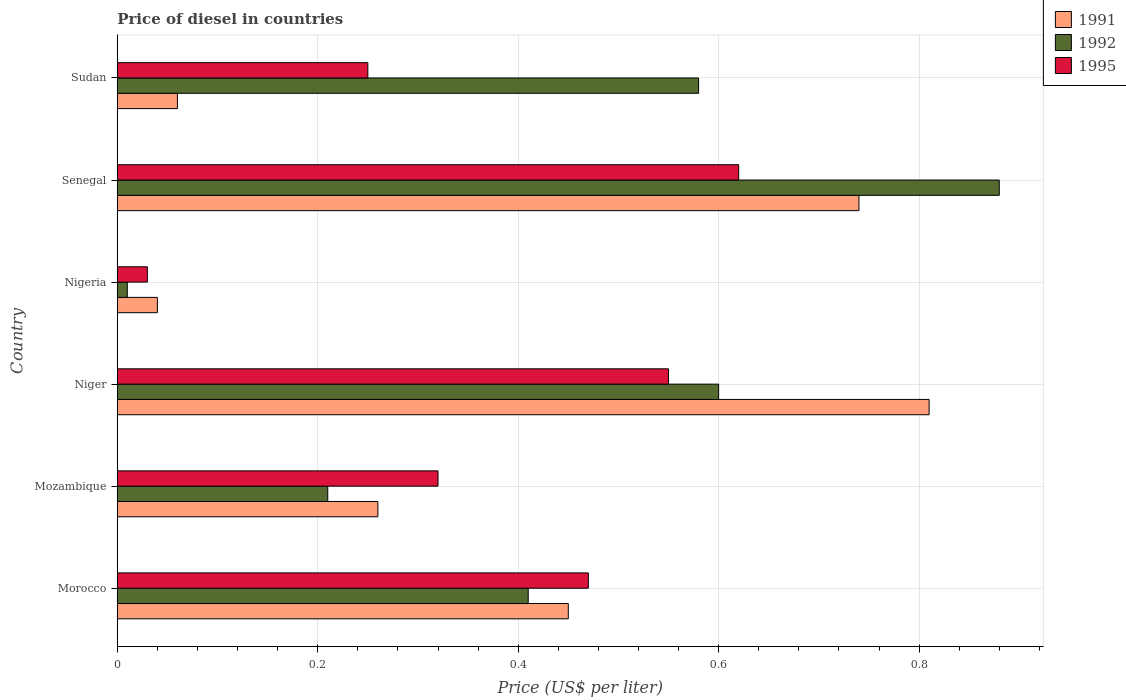What is the label of the 3rd group of bars from the top?
Ensure brevity in your answer.  Nigeria. In how many cases, is the number of bars for a given country not equal to the number of legend labels?
Your answer should be very brief. 0. What is the price of diesel in 1995 in Morocco?
Make the answer very short. 0.47. Across all countries, what is the maximum price of diesel in 1991?
Give a very brief answer. 0.81. In which country was the price of diesel in 1992 maximum?
Provide a succinct answer. Senegal. In which country was the price of diesel in 1991 minimum?
Provide a succinct answer. Nigeria. What is the total price of diesel in 1995 in the graph?
Offer a terse response. 2.24. What is the difference between the price of diesel in 1991 in Senegal and that in Sudan?
Make the answer very short. 0.68. What is the difference between the price of diesel in 1992 in Sudan and the price of diesel in 1991 in Morocco?
Your response must be concise. 0.13. What is the average price of diesel in 1995 per country?
Make the answer very short. 0.37. What is the difference between the price of diesel in 1992 and price of diesel in 1991 in Sudan?
Provide a short and direct response. 0.52. What is the ratio of the price of diesel in 1992 in Nigeria to that in Sudan?
Offer a very short reply. 0.02. Is the price of diesel in 1991 in Morocco less than that in Nigeria?
Give a very brief answer. No. Is the difference between the price of diesel in 1992 in Niger and Sudan greater than the difference between the price of diesel in 1991 in Niger and Sudan?
Your answer should be very brief. No. What is the difference between the highest and the second highest price of diesel in 1991?
Make the answer very short. 0.07. What is the difference between the highest and the lowest price of diesel in 1992?
Offer a very short reply. 0.87. Is the sum of the price of diesel in 1991 in Niger and Senegal greater than the maximum price of diesel in 1992 across all countries?
Your answer should be very brief. Yes. What does the 2nd bar from the top in Mozambique represents?
Your answer should be compact. 1992. Is it the case that in every country, the sum of the price of diesel in 1991 and price of diesel in 1992 is greater than the price of diesel in 1995?
Keep it short and to the point. Yes. How many countries are there in the graph?
Provide a succinct answer. 6. Are the values on the major ticks of X-axis written in scientific E-notation?
Your response must be concise. No. Does the graph contain any zero values?
Your answer should be very brief. No. Does the graph contain grids?
Your answer should be compact. Yes. Where does the legend appear in the graph?
Keep it short and to the point. Top right. What is the title of the graph?
Give a very brief answer. Price of diesel in countries. What is the label or title of the X-axis?
Offer a very short reply. Price (US$ per liter). What is the Price (US$ per liter) in 1991 in Morocco?
Ensure brevity in your answer.  0.45. What is the Price (US$ per liter) in 1992 in Morocco?
Provide a succinct answer. 0.41. What is the Price (US$ per liter) in 1995 in Morocco?
Provide a short and direct response. 0.47. What is the Price (US$ per liter) in 1991 in Mozambique?
Offer a very short reply. 0.26. What is the Price (US$ per liter) of 1992 in Mozambique?
Make the answer very short. 0.21. What is the Price (US$ per liter) in 1995 in Mozambique?
Your response must be concise. 0.32. What is the Price (US$ per liter) of 1991 in Niger?
Give a very brief answer. 0.81. What is the Price (US$ per liter) of 1995 in Niger?
Ensure brevity in your answer.  0.55. What is the Price (US$ per liter) of 1992 in Nigeria?
Ensure brevity in your answer.  0.01. What is the Price (US$ per liter) of 1995 in Nigeria?
Your response must be concise. 0.03. What is the Price (US$ per liter) in 1991 in Senegal?
Your response must be concise. 0.74. What is the Price (US$ per liter) of 1995 in Senegal?
Ensure brevity in your answer.  0.62. What is the Price (US$ per liter) in 1991 in Sudan?
Provide a short and direct response. 0.06. What is the Price (US$ per liter) in 1992 in Sudan?
Give a very brief answer. 0.58. What is the Price (US$ per liter) of 1995 in Sudan?
Keep it short and to the point. 0.25. Across all countries, what is the maximum Price (US$ per liter) in 1991?
Your answer should be compact. 0.81. Across all countries, what is the maximum Price (US$ per liter) in 1995?
Ensure brevity in your answer.  0.62. Across all countries, what is the minimum Price (US$ per liter) in 1995?
Provide a short and direct response. 0.03. What is the total Price (US$ per liter) of 1991 in the graph?
Give a very brief answer. 2.36. What is the total Price (US$ per liter) in 1992 in the graph?
Give a very brief answer. 2.69. What is the total Price (US$ per liter) in 1995 in the graph?
Offer a terse response. 2.24. What is the difference between the Price (US$ per liter) in 1991 in Morocco and that in Mozambique?
Your answer should be compact. 0.19. What is the difference between the Price (US$ per liter) in 1995 in Morocco and that in Mozambique?
Your answer should be compact. 0.15. What is the difference between the Price (US$ per liter) in 1991 in Morocco and that in Niger?
Your answer should be very brief. -0.36. What is the difference between the Price (US$ per liter) of 1992 in Morocco and that in Niger?
Offer a very short reply. -0.19. What is the difference between the Price (US$ per liter) of 1995 in Morocco and that in Niger?
Make the answer very short. -0.08. What is the difference between the Price (US$ per liter) of 1991 in Morocco and that in Nigeria?
Offer a very short reply. 0.41. What is the difference between the Price (US$ per liter) of 1995 in Morocco and that in Nigeria?
Offer a terse response. 0.44. What is the difference between the Price (US$ per liter) in 1991 in Morocco and that in Senegal?
Give a very brief answer. -0.29. What is the difference between the Price (US$ per liter) in 1992 in Morocco and that in Senegal?
Your answer should be compact. -0.47. What is the difference between the Price (US$ per liter) in 1995 in Morocco and that in Senegal?
Provide a short and direct response. -0.15. What is the difference between the Price (US$ per liter) of 1991 in Morocco and that in Sudan?
Your answer should be very brief. 0.39. What is the difference between the Price (US$ per liter) in 1992 in Morocco and that in Sudan?
Provide a short and direct response. -0.17. What is the difference between the Price (US$ per liter) of 1995 in Morocco and that in Sudan?
Offer a very short reply. 0.22. What is the difference between the Price (US$ per liter) of 1991 in Mozambique and that in Niger?
Give a very brief answer. -0.55. What is the difference between the Price (US$ per liter) in 1992 in Mozambique and that in Niger?
Your answer should be compact. -0.39. What is the difference between the Price (US$ per liter) of 1995 in Mozambique and that in Niger?
Your response must be concise. -0.23. What is the difference between the Price (US$ per liter) in 1991 in Mozambique and that in Nigeria?
Give a very brief answer. 0.22. What is the difference between the Price (US$ per liter) in 1992 in Mozambique and that in Nigeria?
Provide a short and direct response. 0.2. What is the difference between the Price (US$ per liter) of 1995 in Mozambique and that in Nigeria?
Your answer should be compact. 0.29. What is the difference between the Price (US$ per liter) of 1991 in Mozambique and that in Senegal?
Ensure brevity in your answer.  -0.48. What is the difference between the Price (US$ per liter) in 1992 in Mozambique and that in Senegal?
Ensure brevity in your answer.  -0.67. What is the difference between the Price (US$ per liter) of 1995 in Mozambique and that in Senegal?
Give a very brief answer. -0.3. What is the difference between the Price (US$ per liter) of 1992 in Mozambique and that in Sudan?
Offer a terse response. -0.37. What is the difference between the Price (US$ per liter) of 1995 in Mozambique and that in Sudan?
Your answer should be very brief. 0.07. What is the difference between the Price (US$ per liter) in 1991 in Niger and that in Nigeria?
Provide a succinct answer. 0.77. What is the difference between the Price (US$ per liter) in 1992 in Niger and that in Nigeria?
Offer a very short reply. 0.59. What is the difference between the Price (US$ per liter) of 1995 in Niger and that in Nigeria?
Ensure brevity in your answer.  0.52. What is the difference between the Price (US$ per liter) of 1991 in Niger and that in Senegal?
Ensure brevity in your answer.  0.07. What is the difference between the Price (US$ per liter) of 1992 in Niger and that in Senegal?
Ensure brevity in your answer.  -0.28. What is the difference between the Price (US$ per liter) in 1995 in Niger and that in Senegal?
Your answer should be very brief. -0.07. What is the difference between the Price (US$ per liter) in 1991 in Niger and that in Sudan?
Keep it short and to the point. 0.75. What is the difference between the Price (US$ per liter) of 1992 in Nigeria and that in Senegal?
Your answer should be compact. -0.87. What is the difference between the Price (US$ per liter) in 1995 in Nigeria and that in Senegal?
Provide a succinct answer. -0.59. What is the difference between the Price (US$ per liter) of 1991 in Nigeria and that in Sudan?
Offer a very short reply. -0.02. What is the difference between the Price (US$ per liter) in 1992 in Nigeria and that in Sudan?
Keep it short and to the point. -0.57. What is the difference between the Price (US$ per liter) of 1995 in Nigeria and that in Sudan?
Provide a short and direct response. -0.22. What is the difference between the Price (US$ per liter) in 1991 in Senegal and that in Sudan?
Keep it short and to the point. 0.68. What is the difference between the Price (US$ per liter) of 1992 in Senegal and that in Sudan?
Provide a short and direct response. 0.3. What is the difference between the Price (US$ per liter) in 1995 in Senegal and that in Sudan?
Ensure brevity in your answer.  0.37. What is the difference between the Price (US$ per liter) of 1991 in Morocco and the Price (US$ per liter) of 1992 in Mozambique?
Keep it short and to the point. 0.24. What is the difference between the Price (US$ per liter) of 1991 in Morocco and the Price (US$ per liter) of 1995 in Mozambique?
Keep it short and to the point. 0.13. What is the difference between the Price (US$ per liter) of 1992 in Morocco and the Price (US$ per liter) of 1995 in Mozambique?
Make the answer very short. 0.09. What is the difference between the Price (US$ per liter) of 1991 in Morocco and the Price (US$ per liter) of 1992 in Niger?
Provide a succinct answer. -0.15. What is the difference between the Price (US$ per liter) in 1992 in Morocco and the Price (US$ per liter) in 1995 in Niger?
Your answer should be very brief. -0.14. What is the difference between the Price (US$ per liter) in 1991 in Morocco and the Price (US$ per liter) in 1992 in Nigeria?
Make the answer very short. 0.44. What is the difference between the Price (US$ per liter) in 1991 in Morocco and the Price (US$ per liter) in 1995 in Nigeria?
Your answer should be very brief. 0.42. What is the difference between the Price (US$ per liter) of 1992 in Morocco and the Price (US$ per liter) of 1995 in Nigeria?
Your response must be concise. 0.38. What is the difference between the Price (US$ per liter) of 1991 in Morocco and the Price (US$ per liter) of 1992 in Senegal?
Give a very brief answer. -0.43. What is the difference between the Price (US$ per liter) of 1991 in Morocco and the Price (US$ per liter) of 1995 in Senegal?
Your answer should be compact. -0.17. What is the difference between the Price (US$ per liter) of 1992 in Morocco and the Price (US$ per liter) of 1995 in Senegal?
Provide a succinct answer. -0.21. What is the difference between the Price (US$ per liter) of 1991 in Morocco and the Price (US$ per liter) of 1992 in Sudan?
Offer a terse response. -0.13. What is the difference between the Price (US$ per liter) of 1992 in Morocco and the Price (US$ per liter) of 1995 in Sudan?
Your answer should be very brief. 0.16. What is the difference between the Price (US$ per liter) of 1991 in Mozambique and the Price (US$ per liter) of 1992 in Niger?
Your answer should be compact. -0.34. What is the difference between the Price (US$ per liter) of 1991 in Mozambique and the Price (US$ per liter) of 1995 in Niger?
Provide a short and direct response. -0.29. What is the difference between the Price (US$ per liter) in 1992 in Mozambique and the Price (US$ per liter) in 1995 in Niger?
Give a very brief answer. -0.34. What is the difference between the Price (US$ per liter) in 1991 in Mozambique and the Price (US$ per liter) in 1995 in Nigeria?
Provide a short and direct response. 0.23. What is the difference between the Price (US$ per liter) of 1992 in Mozambique and the Price (US$ per liter) of 1995 in Nigeria?
Your answer should be compact. 0.18. What is the difference between the Price (US$ per liter) in 1991 in Mozambique and the Price (US$ per liter) in 1992 in Senegal?
Offer a terse response. -0.62. What is the difference between the Price (US$ per liter) of 1991 in Mozambique and the Price (US$ per liter) of 1995 in Senegal?
Offer a very short reply. -0.36. What is the difference between the Price (US$ per liter) of 1992 in Mozambique and the Price (US$ per liter) of 1995 in Senegal?
Your answer should be compact. -0.41. What is the difference between the Price (US$ per liter) in 1991 in Mozambique and the Price (US$ per liter) in 1992 in Sudan?
Make the answer very short. -0.32. What is the difference between the Price (US$ per liter) of 1992 in Mozambique and the Price (US$ per liter) of 1995 in Sudan?
Offer a very short reply. -0.04. What is the difference between the Price (US$ per liter) of 1991 in Niger and the Price (US$ per liter) of 1995 in Nigeria?
Give a very brief answer. 0.78. What is the difference between the Price (US$ per liter) in 1992 in Niger and the Price (US$ per liter) in 1995 in Nigeria?
Keep it short and to the point. 0.57. What is the difference between the Price (US$ per liter) of 1991 in Niger and the Price (US$ per liter) of 1992 in Senegal?
Make the answer very short. -0.07. What is the difference between the Price (US$ per liter) of 1991 in Niger and the Price (US$ per liter) of 1995 in Senegal?
Ensure brevity in your answer.  0.19. What is the difference between the Price (US$ per liter) in 1992 in Niger and the Price (US$ per liter) in 1995 in Senegal?
Offer a terse response. -0.02. What is the difference between the Price (US$ per liter) in 1991 in Niger and the Price (US$ per liter) in 1992 in Sudan?
Your answer should be compact. 0.23. What is the difference between the Price (US$ per liter) in 1991 in Niger and the Price (US$ per liter) in 1995 in Sudan?
Your answer should be very brief. 0.56. What is the difference between the Price (US$ per liter) of 1992 in Niger and the Price (US$ per liter) of 1995 in Sudan?
Offer a very short reply. 0.35. What is the difference between the Price (US$ per liter) of 1991 in Nigeria and the Price (US$ per liter) of 1992 in Senegal?
Give a very brief answer. -0.84. What is the difference between the Price (US$ per liter) in 1991 in Nigeria and the Price (US$ per liter) in 1995 in Senegal?
Offer a terse response. -0.58. What is the difference between the Price (US$ per liter) of 1992 in Nigeria and the Price (US$ per liter) of 1995 in Senegal?
Your answer should be very brief. -0.61. What is the difference between the Price (US$ per liter) of 1991 in Nigeria and the Price (US$ per liter) of 1992 in Sudan?
Provide a short and direct response. -0.54. What is the difference between the Price (US$ per liter) in 1991 in Nigeria and the Price (US$ per liter) in 1995 in Sudan?
Give a very brief answer. -0.21. What is the difference between the Price (US$ per liter) in 1992 in Nigeria and the Price (US$ per liter) in 1995 in Sudan?
Provide a succinct answer. -0.24. What is the difference between the Price (US$ per liter) of 1991 in Senegal and the Price (US$ per liter) of 1992 in Sudan?
Provide a short and direct response. 0.16. What is the difference between the Price (US$ per liter) of 1991 in Senegal and the Price (US$ per liter) of 1995 in Sudan?
Give a very brief answer. 0.49. What is the difference between the Price (US$ per liter) in 1992 in Senegal and the Price (US$ per liter) in 1995 in Sudan?
Give a very brief answer. 0.63. What is the average Price (US$ per liter) in 1991 per country?
Your answer should be very brief. 0.39. What is the average Price (US$ per liter) in 1992 per country?
Ensure brevity in your answer.  0.45. What is the average Price (US$ per liter) of 1995 per country?
Give a very brief answer. 0.37. What is the difference between the Price (US$ per liter) of 1991 and Price (US$ per liter) of 1992 in Morocco?
Your answer should be compact. 0.04. What is the difference between the Price (US$ per liter) of 1991 and Price (US$ per liter) of 1995 in Morocco?
Ensure brevity in your answer.  -0.02. What is the difference between the Price (US$ per liter) in 1992 and Price (US$ per liter) in 1995 in Morocco?
Ensure brevity in your answer.  -0.06. What is the difference between the Price (US$ per liter) in 1991 and Price (US$ per liter) in 1992 in Mozambique?
Keep it short and to the point. 0.05. What is the difference between the Price (US$ per liter) of 1991 and Price (US$ per liter) of 1995 in Mozambique?
Provide a succinct answer. -0.06. What is the difference between the Price (US$ per liter) in 1992 and Price (US$ per liter) in 1995 in Mozambique?
Ensure brevity in your answer.  -0.11. What is the difference between the Price (US$ per liter) in 1991 and Price (US$ per liter) in 1992 in Niger?
Provide a short and direct response. 0.21. What is the difference between the Price (US$ per liter) of 1991 and Price (US$ per liter) of 1995 in Niger?
Provide a succinct answer. 0.26. What is the difference between the Price (US$ per liter) of 1992 and Price (US$ per liter) of 1995 in Niger?
Your answer should be very brief. 0.05. What is the difference between the Price (US$ per liter) of 1991 and Price (US$ per liter) of 1992 in Nigeria?
Your response must be concise. 0.03. What is the difference between the Price (US$ per liter) of 1992 and Price (US$ per liter) of 1995 in Nigeria?
Provide a short and direct response. -0.02. What is the difference between the Price (US$ per liter) in 1991 and Price (US$ per liter) in 1992 in Senegal?
Offer a very short reply. -0.14. What is the difference between the Price (US$ per liter) of 1991 and Price (US$ per liter) of 1995 in Senegal?
Your answer should be compact. 0.12. What is the difference between the Price (US$ per liter) in 1992 and Price (US$ per liter) in 1995 in Senegal?
Give a very brief answer. 0.26. What is the difference between the Price (US$ per liter) in 1991 and Price (US$ per liter) in 1992 in Sudan?
Offer a terse response. -0.52. What is the difference between the Price (US$ per liter) of 1991 and Price (US$ per liter) of 1995 in Sudan?
Your response must be concise. -0.19. What is the difference between the Price (US$ per liter) of 1992 and Price (US$ per liter) of 1995 in Sudan?
Provide a short and direct response. 0.33. What is the ratio of the Price (US$ per liter) of 1991 in Morocco to that in Mozambique?
Keep it short and to the point. 1.73. What is the ratio of the Price (US$ per liter) of 1992 in Morocco to that in Mozambique?
Offer a very short reply. 1.95. What is the ratio of the Price (US$ per liter) in 1995 in Morocco to that in Mozambique?
Provide a succinct answer. 1.47. What is the ratio of the Price (US$ per liter) of 1991 in Morocco to that in Niger?
Make the answer very short. 0.56. What is the ratio of the Price (US$ per liter) in 1992 in Morocco to that in Niger?
Provide a short and direct response. 0.68. What is the ratio of the Price (US$ per liter) of 1995 in Morocco to that in Niger?
Offer a terse response. 0.85. What is the ratio of the Price (US$ per liter) of 1991 in Morocco to that in Nigeria?
Keep it short and to the point. 11.25. What is the ratio of the Price (US$ per liter) in 1995 in Morocco to that in Nigeria?
Provide a succinct answer. 15.67. What is the ratio of the Price (US$ per liter) of 1991 in Morocco to that in Senegal?
Offer a very short reply. 0.61. What is the ratio of the Price (US$ per liter) in 1992 in Morocco to that in Senegal?
Give a very brief answer. 0.47. What is the ratio of the Price (US$ per liter) in 1995 in Morocco to that in Senegal?
Provide a short and direct response. 0.76. What is the ratio of the Price (US$ per liter) of 1991 in Morocco to that in Sudan?
Your answer should be very brief. 7.5. What is the ratio of the Price (US$ per liter) of 1992 in Morocco to that in Sudan?
Ensure brevity in your answer.  0.71. What is the ratio of the Price (US$ per liter) in 1995 in Morocco to that in Sudan?
Your answer should be compact. 1.88. What is the ratio of the Price (US$ per liter) in 1991 in Mozambique to that in Niger?
Your answer should be very brief. 0.32. What is the ratio of the Price (US$ per liter) of 1992 in Mozambique to that in Niger?
Keep it short and to the point. 0.35. What is the ratio of the Price (US$ per liter) of 1995 in Mozambique to that in Niger?
Your response must be concise. 0.58. What is the ratio of the Price (US$ per liter) in 1992 in Mozambique to that in Nigeria?
Offer a very short reply. 21. What is the ratio of the Price (US$ per liter) of 1995 in Mozambique to that in Nigeria?
Ensure brevity in your answer.  10.67. What is the ratio of the Price (US$ per liter) of 1991 in Mozambique to that in Senegal?
Offer a very short reply. 0.35. What is the ratio of the Price (US$ per liter) in 1992 in Mozambique to that in Senegal?
Offer a terse response. 0.24. What is the ratio of the Price (US$ per liter) of 1995 in Mozambique to that in Senegal?
Ensure brevity in your answer.  0.52. What is the ratio of the Price (US$ per liter) of 1991 in Mozambique to that in Sudan?
Offer a very short reply. 4.33. What is the ratio of the Price (US$ per liter) of 1992 in Mozambique to that in Sudan?
Give a very brief answer. 0.36. What is the ratio of the Price (US$ per liter) in 1995 in Mozambique to that in Sudan?
Ensure brevity in your answer.  1.28. What is the ratio of the Price (US$ per liter) of 1991 in Niger to that in Nigeria?
Provide a succinct answer. 20.25. What is the ratio of the Price (US$ per liter) of 1995 in Niger to that in Nigeria?
Your answer should be very brief. 18.33. What is the ratio of the Price (US$ per liter) of 1991 in Niger to that in Senegal?
Your response must be concise. 1.09. What is the ratio of the Price (US$ per liter) in 1992 in Niger to that in Senegal?
Keep it short and to the point. 0.68. What is the ratio of the Price (US$ per liter) of 1995 in Niger to that in Senegal?
Your answer should be compact. 0.89. What is the ratio of the Price (US$ per liter) of 1992 in Niger to that in Sudan?
Your response must be concise. 1.03. What is the ratio of the Price (US$ per liter) in 1995 in Niger to that in Sudan?
Keep it short and to the point. 2.2. What is the ratio of the Price (US$ per liter) in 1991 in Nigeria to that in Senegal?
Your response must be concise. 0.05. What is the ratio of the Price (US$ per liter) of 1992 in Nigeria to that in Senegal?
Provide a succinct answer. 0.01. What is the ratio of the Price (US$ per liter) in 1995 in Nigeria to that in Senegal?
Provide a succinct answer. 0.05. What is the ratio of the Price (US$ per liter) of 1991 in Nigeria to that in Sudan?
Offer a terse response. 0.67. What is the ratio of the Price (US$ per liter) of 1992 in Nigeria to that in Sudan?
Ensure brevity in your answer.  0.02. What is the ratio of the Price (US$ per liter) in 1995 in Nigeria to that in Sudan?
Your answer should be compact. 0.12. What is the ratio of the Price (US$ per liter) in 1991 in Senegal to that in Sudan?
Your response must be concise. 12.33. What is the ratio of the Price (US$ per liter) of 1992 in Senegal to that in Sudan?
Keep it short and to the point. 1.52. What is the ratio of the Price (US$ per liter) of 1995 in Senegal to that in Sudan?
Your answer should be very brief. 2.48. What is the difference between the highest and the second highest Price (US$ per liter) in 1991?
Offer a very short reply. 0.07. What is the difference between the highest and the second highest Price (US$ per liter) of 1992?
Your response must be concise. 0.28. What is the difference between the highest and the second highest Price (US$ per liter) of 1995?
Offer a terse response. 0.07. What is the difference between the highest and the lowest Price (US$ per liter) of 1991?
Give a very brief answer. 0.77. What is the difference between the highest and the lowest Price (US$ per liter) of 1992?
Offer a very short reply. 0.87. What is the difference between the highest and the lowest Price (US$ per liter) in 1995?
Make the answer very short. 0.59. 